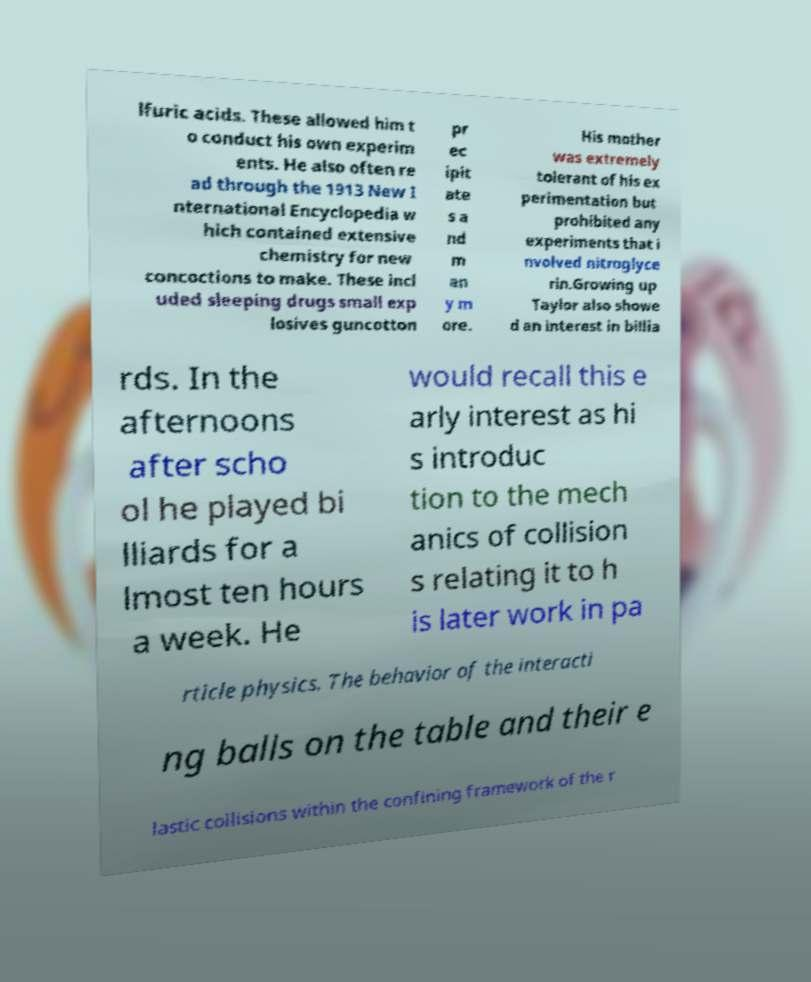Could you extract and type out the text from this image? lfuric acids. These allowed him t o conduct his own experim ents. He also often re ad through the 1913 New I nternational Encyclopedia w hich contained extensive chemistry for new concoctions to make. These incl uded sleeping drugs small exp losives guncotton pr ec ipit ate s a nd m an y m ore. His mother was extremely tolerant of his ex perimentation but prohibited any experiments that i nvolved nitroglyce rin.Growing up Taylor also showe d an interest in billia rds. In the afternoons after scho ol he played bi lliards for a lmost ten hours a week. He would recall this e arly interest as hi s introduc tion to the mech anics of collision s relating it to h is later work in pa rticle physics. The behavior of the interacti ng balls on the table and their e lastic collisions within the confining framework of the r 